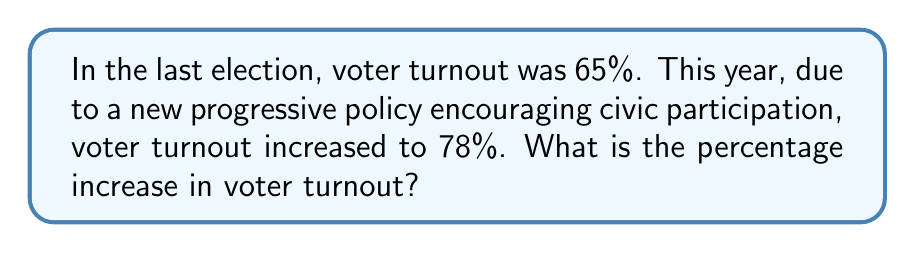Solve this math problem. To calculate the percentage increase in voter turnout, we need to follow these steps:

1. Calculate the difference between the new and old voter turnout:
   $78\% - 65\% = 13\%$

2. Divide this difference by the original voter turnout:
   $$\frac{13\%}{65\%} = 0.2$$

3. Convert the result to a percentage by multiplying by 100:
   $$0.2 \times 100 = 20\%$$

Therefore, the percentage increase in voter turnout is 20%.

Alternatively, we can use the percentage increase formula:

$$\text{Percentage Increase} = \frac{\text{New Value} - \text{Original Value}}{\text{Original Value}} \times 100\%$$

$$\text{Percentage Increase} = \frac{78\% - 65\%}{65\%} \times 100\% = \frac{13\%}{65\%} \times 100\% = 20\%$$
Answer: 20% 